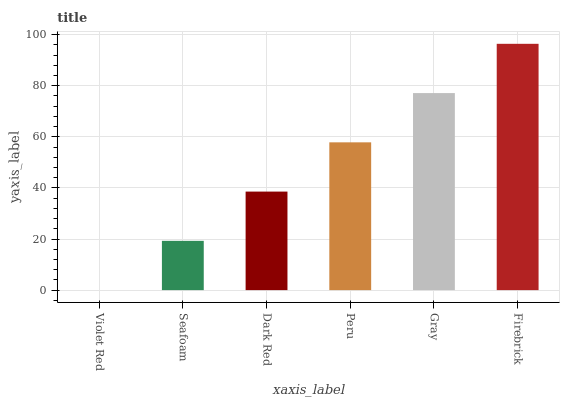Is Violet Red the minimum?
Answer yes or no. Yes. Is Firebrick the maximum?
Answer yes or no. Yes. Is Seafoam the minimum?
Answer yes or no. No. Is Seafoam the maximum?
Answer yes or no. No. Is Seafoam greater than Violet Red?
Answer yes or no. Yes. Is Violet Red less than Seafoam?
Answer yes or no. Yes. Is Violet Red greater than Seafoam?
Answer yes or no. No. Is Seafoam less than Violet Red?
Answer yes or no. No. Is Peru the high median?
Answer yes or no. Yes. Is Dark Red the low median?
Answer yes or no. Yes. Is Violet Red the high median?
Answer yes or no. No. Is Peru the low median?
Answer yes or no. No. 